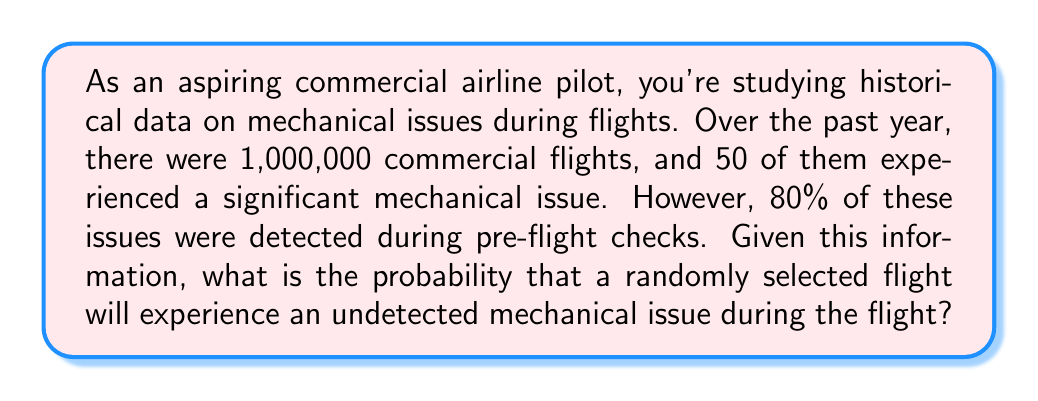What is the answer to this math problem? Let's approach this problem using Bayesian probability:

1) First, let's define our events:
   A: A flight experiences a significant mechanical issue
   B: A mechanical issue is undetected during pre-flight checks

2) We're given the following information:
   - Total flights: 1,000,000
   - Flights with significant mechanical issues: 50
   - 80% of issues were detected during pre-flight checks, meaning 20% were undetected

3) We can calculate:
   $P(A) = \frac{50}{1,000,000} = 5 \times 10^{-5}$

   $P(B|A) = 0.2$ (probability of an issue being undetected given that there is an issue)

4) We want to find $P(A \cap B)$, which is the probability of both having an issue and it being undetected:

   $P(A \cap B) = P(A) \times P(B|A)$

5) Substituting our values:

   $P(A \cap B) = (5 \times 10^{-5}) \times 0.2 = 1 \times 10^{-5}$

This means that out of 1,000,000 flights, we expect 10 to have an undetected mechanical issue during the flight.

6) To express this as a probability:

   $P(\text{undetected issue}) = \frac{10}{1,000,000} = 1 \times 10^{-5}$
Answer: $1 \times 10^{-5}$ or 0.00001 or 0.001% 